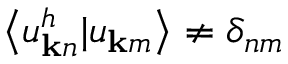<formula> <loc_0><loc_0><loc_500><loc_500>\left < u _ { { k } n } ^ { h } | u _ { { k } m } \right > \ne \delta _ { n m }</formula> 